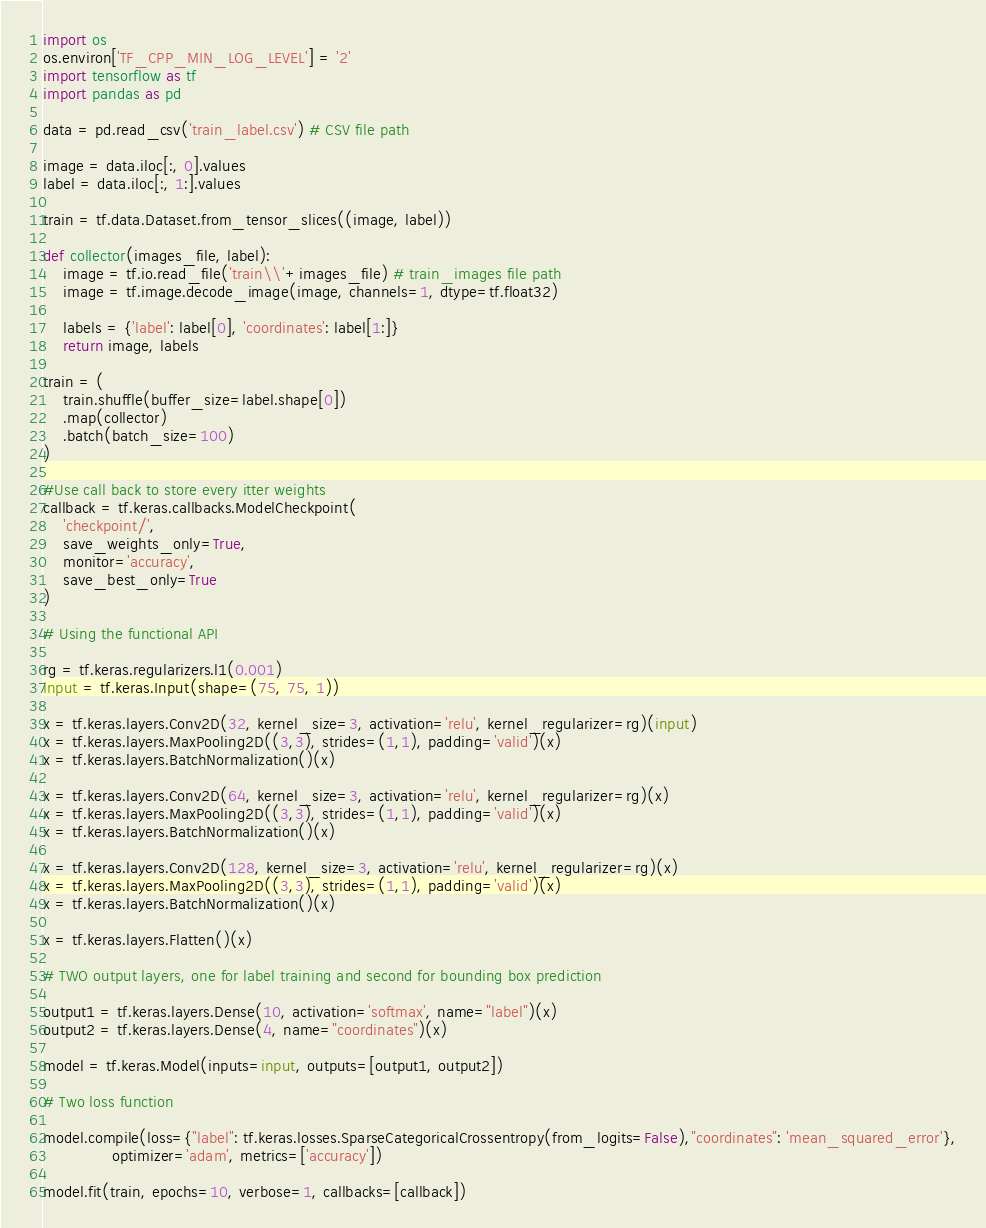<code> <loc_0><loc_0><loc_500><loc_500><_Python_>import os
os.environ['TF_CPP_MIN_LOG_LEVEL'] = '2'
import tensorflow as tf
import pandas as pd

data = pd.read_csv('train_label.csv') # CSV file path

image = data.iloc[:, 0].values
label = data.iloc[:, 1:].values

train = tf.data.Dataset.from_tensor_slices((image, label))

def collector(images_file, label):
    image = tf.io.read_file('train\\'+images_file) # train_images file path
    image = tf.image.decode_image(image, channels=1, dtype=tf.float32)

    labels = {'label': label[0], 'coordinates': label[1:]}
    return image, labels

train = (
    train.shuffle(buffer_size=label.shape[0])
    .map(collector)
    .batch(batch_size=100)
)

#Use call back to store every itter weights
callback = tf.keras.callbacks.ModelCheckpoint(
    'checkpoint/',
    save_weights_only=True,
    monitor='accuracy',
    save_best_only=True
)

# Using the functional API

rg = tf.keras.regularizers.l1(0.001)
input = tf.keras.Input(shape=(75, 75, 1))

x = tf.keras.layers.Conv2D(32, kernel_size=3, activation='relu', kernel_regularizer=rg)(input)
x = tf.keras.layers.MaxPooling2D((3,3), strides=(1,1), padding='valid')(x)
x = tf.keras.layers.BatchNormalization()(x)

x = tf.keras.layers.Conv2D(64, kernel_size=3, activation='relu', kernel_regularizer=rg)(x)
x = tf.keras.layers.MaxPooling2D((3,3), strides=(1,1), padding='valid')(x)
x = tf.keras.layers.BatchNormalization()(x)

x = tf.keras.layers.Conv2D(128, kernel_size=3, activation='relu', kernel_regularizer=rg)(x)
x = tf.keras.layers.MaxPooling2D((3,3), strides=(1,1), padding='valid')(x)
x = tf.keras.layers.BatchNormalization()(x)

x = tf.keras.layers.Flatten()(x)

# TWO output layers, one for label training and second for bounding box prediction

output1 = tf.keras.layers.Dense(10, activation='softmax', name="label")(x)
output2 = tf.keras.layers.Dense(4, name="coordinates")(x)

model = tf.keras.Model(inputs=input, outputs=[output1, output2])

# Two loss function

model.compile(loss={"label": tf.keras.losses.SparseCategoricalCrossentropy(from_logits=False),"coordinates": 'mean_squared_error'},
              optimizer='adam', metrics=['accuracy'])

model.fit(train, epochs=10, verbose=1, callbacks=[callback])</code> 